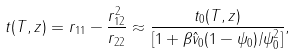<formula> <loc_0><loc_0><loc_500><loc_500>t ( T , z ) = r _ { 1 1 } - \frac { r _ { 1 2 } ^ { 2 } } { r _ { 2 2 } } \approx \frac { t _ { 0 } ( T , z ) } { [ 1 + \beta { \hat { v } } _ { 0 } ( 1 - { \psi } _ { 0 } ) / { \psi } _ { 0 } ^ { 2 } ] } ,</formula> 